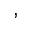Convert formula to latex. <formula><loc_0><loc_0><loc_500><loc_500>^ { , }</formula> 